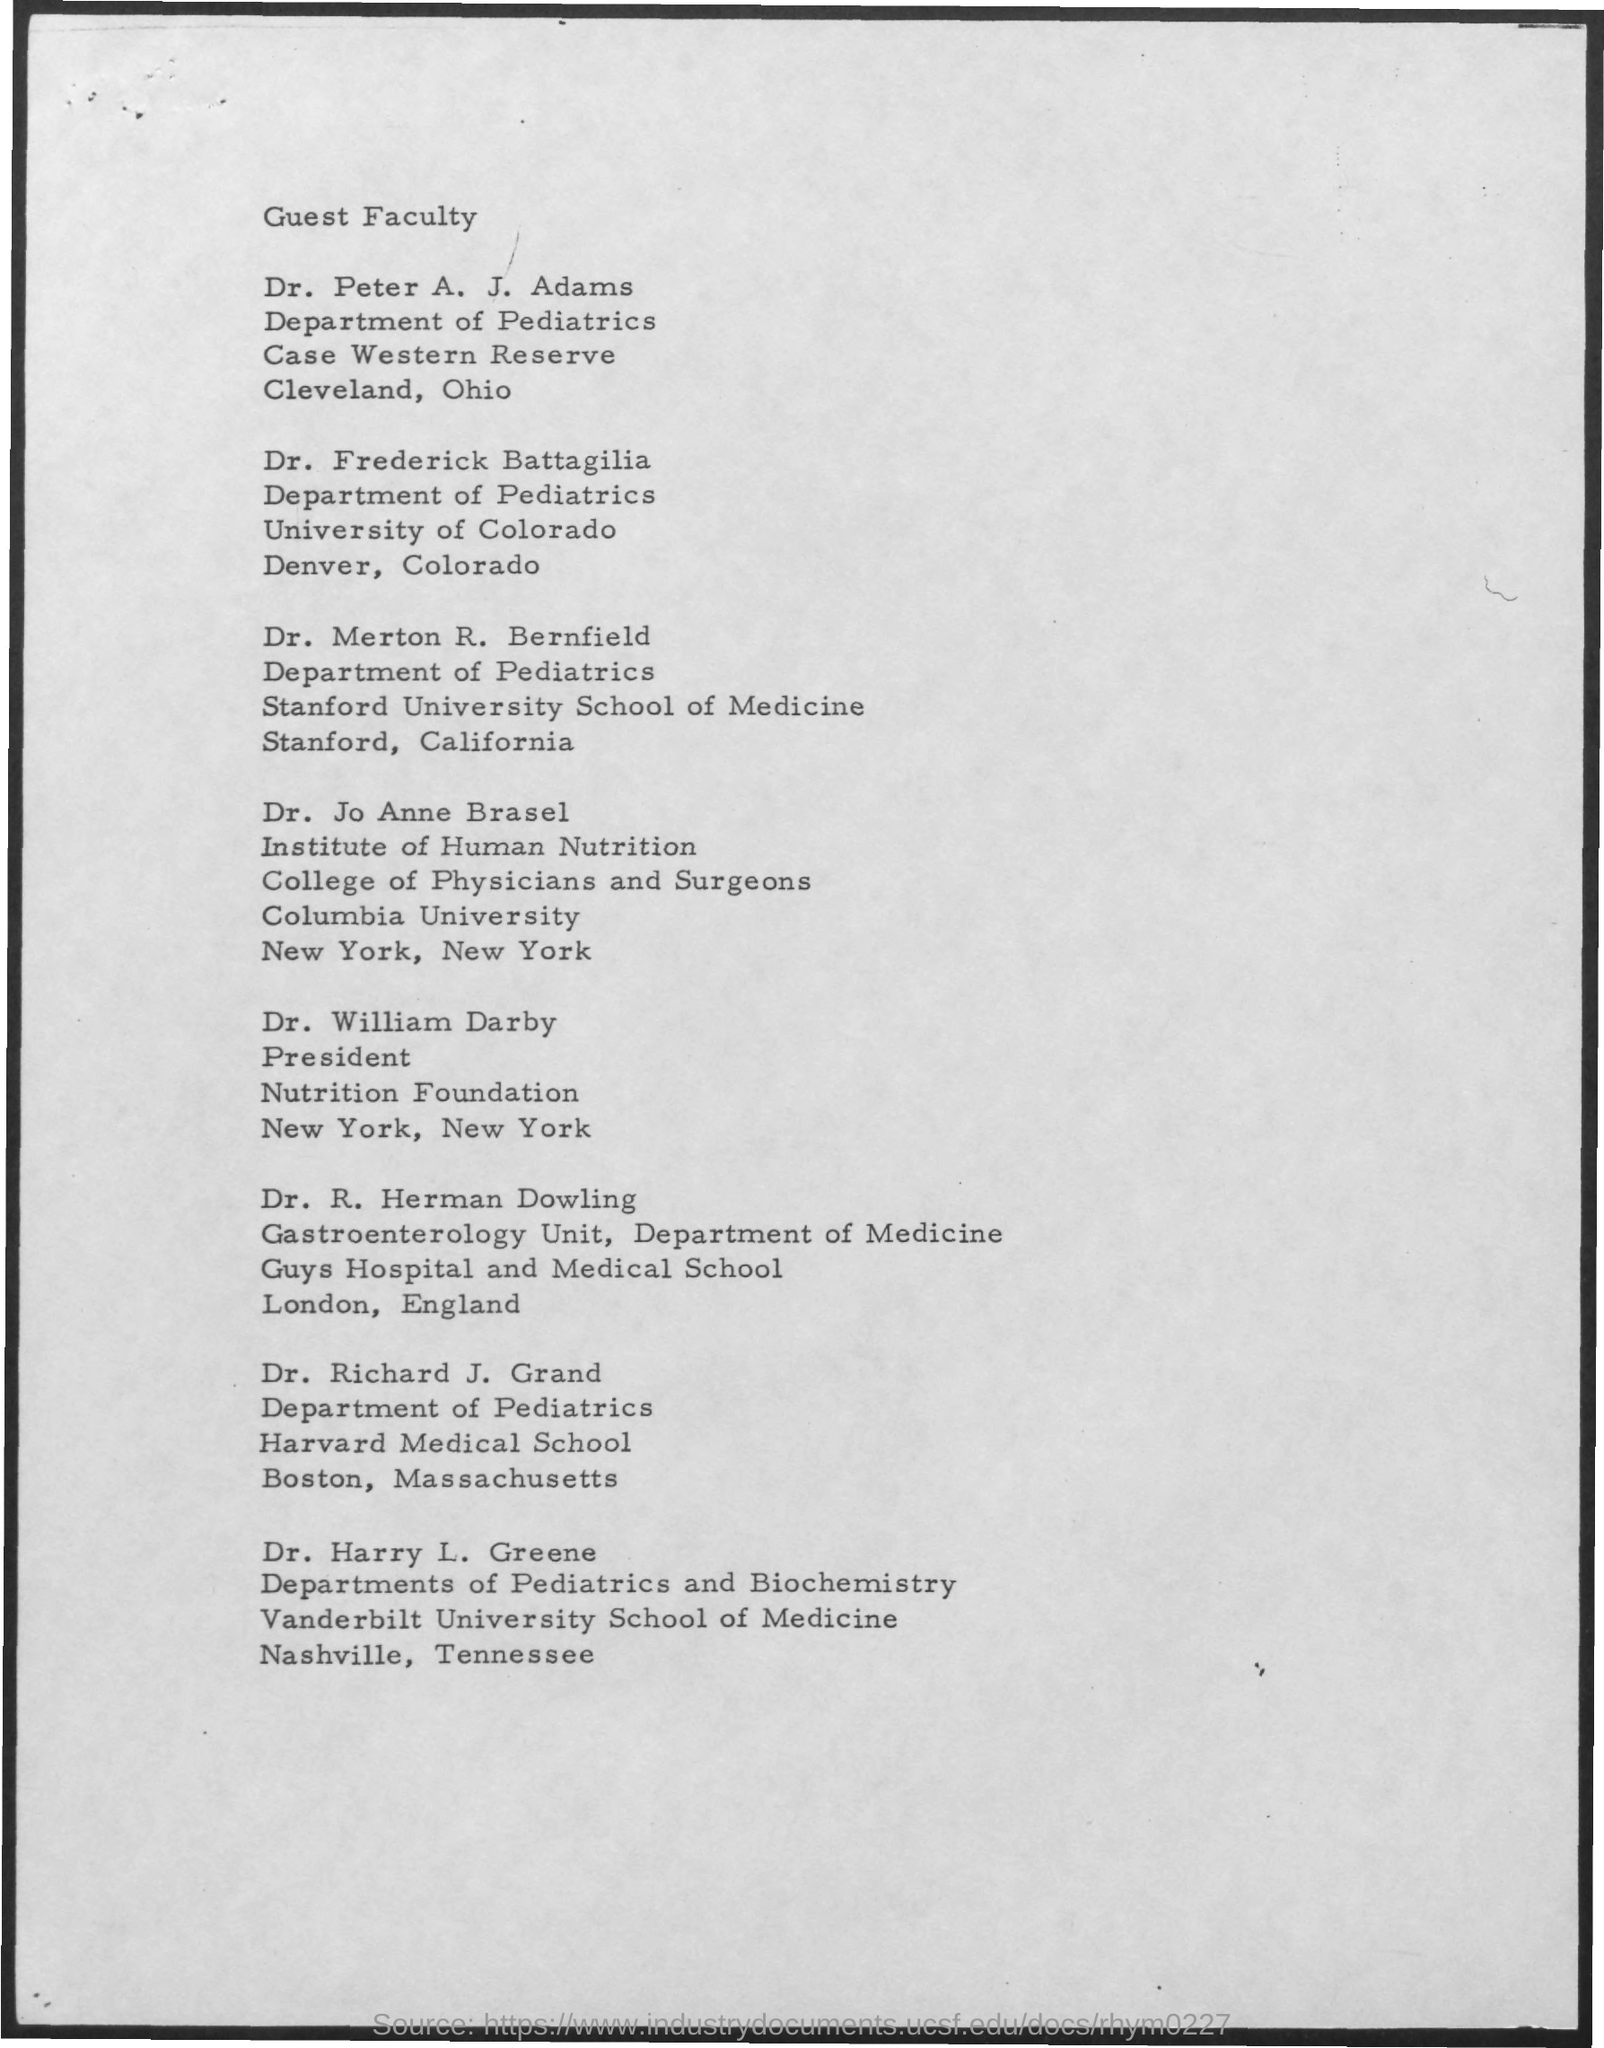What is the first title in the document?
Ensure brevity in your answer.  Guest Faculty. 